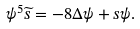<formula> <loc_0><loc_0><loc_500><loc_500>\psi ^ { 5 } \widetilde { s } = - 8 \Delta \psi + s \psi .</formula> 